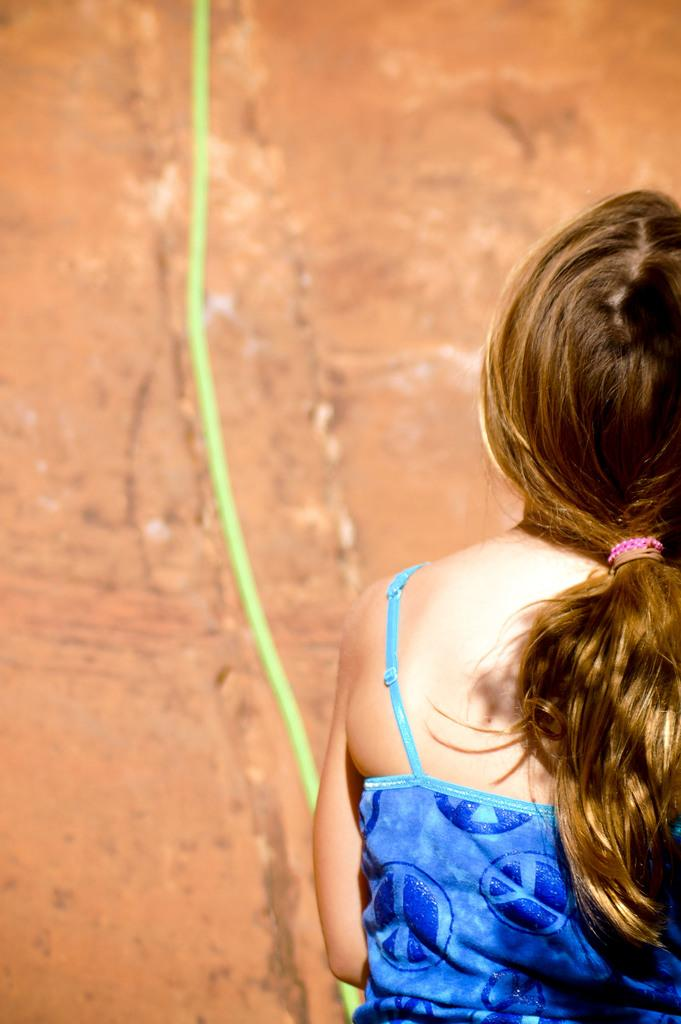Who is present in the image? There is a girl in the image. What can be seen in the background of the image? There is an object in the background of the image. What is the color of the object in the background? The object is green in color. What type of engine can be seen in the image? There is no engine present in the image. 